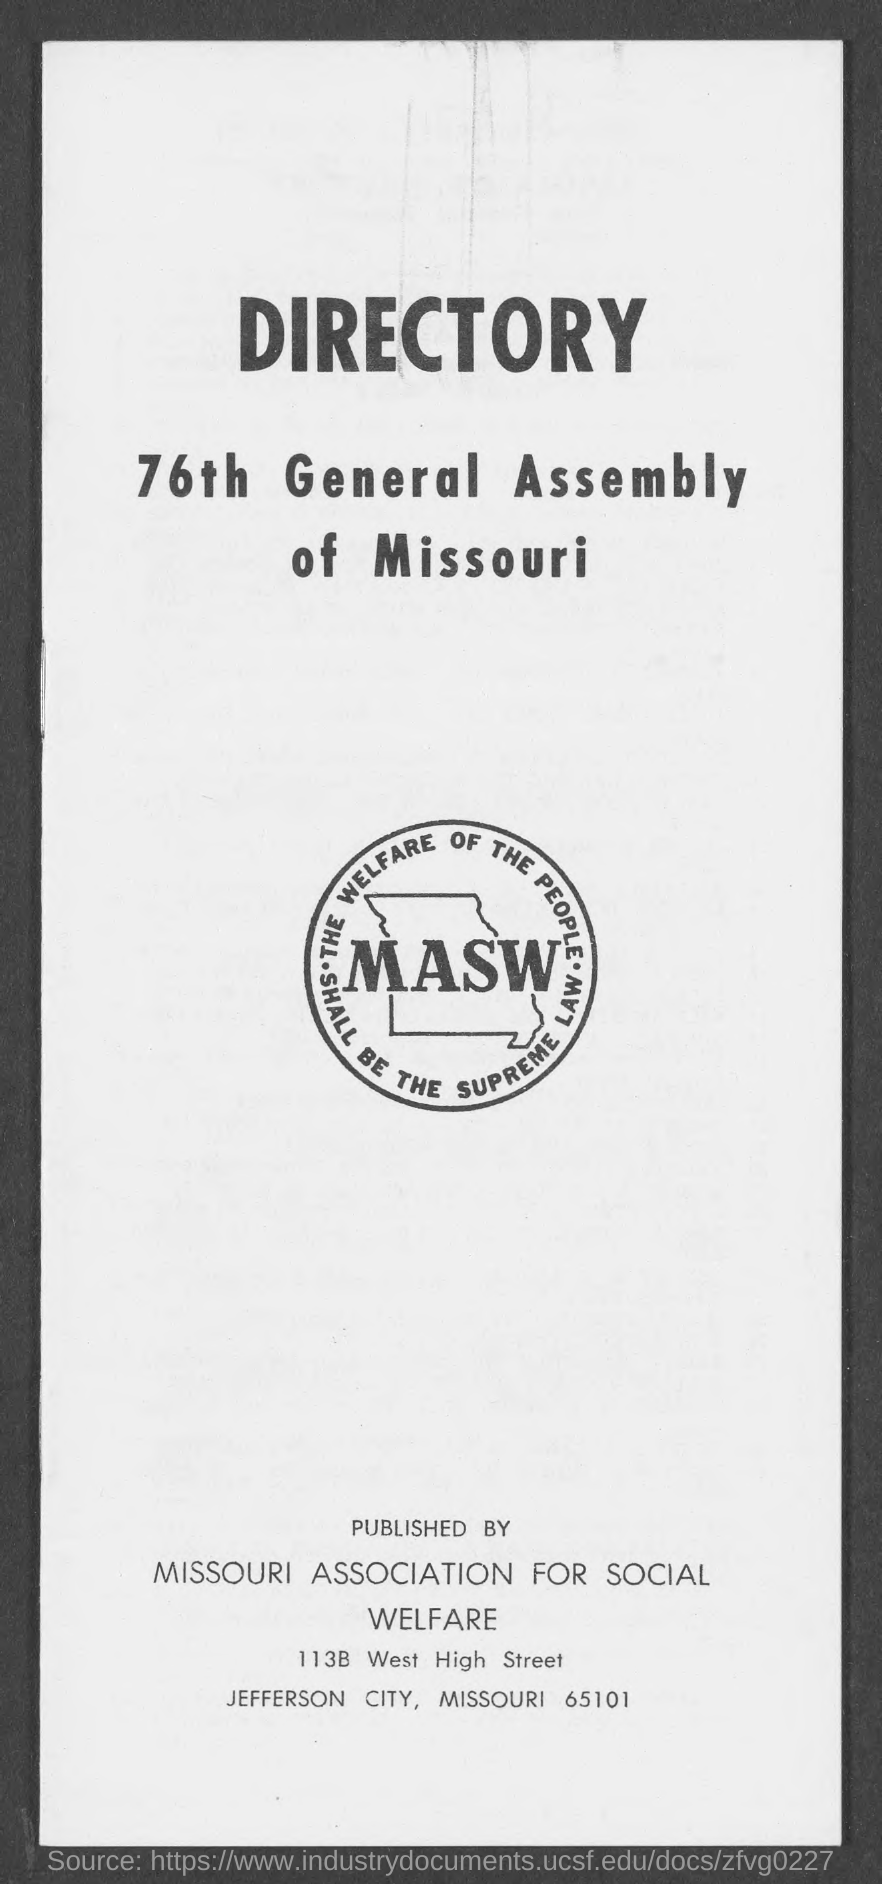Give some essential details in this illustration. The publisher of this material is the MISSOURI association for social welfare. The General Assembly is located in the state of Missouri. 